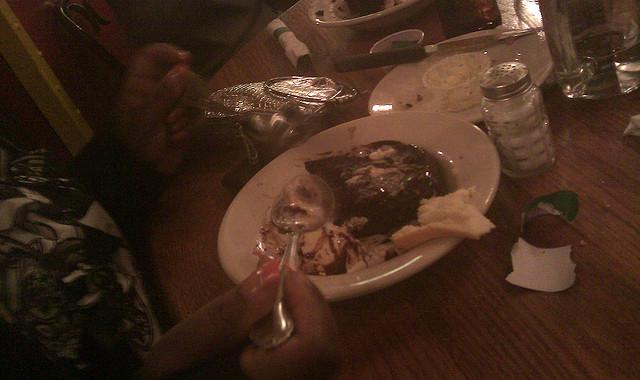Who made this dinner?
Give a very brief answer. Chef. What is the source of protein in this meal?
Give a very brief answer. Steak. What kind of food is on the plate?
Quick response, please. Steak. 